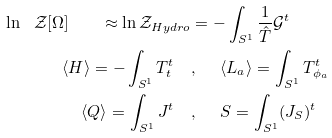<formula> <loc_0><loc_0><loc_500><loc_500>\ln \ \mathcal { Z } [ \Omega ] \quad \approx \ln \mathcal { Z } _ { H y d r o } & = - \int _ { S ^ { 1 } } \frac { 1 } { \hat { T } } \mathcal { G } ^ { t } \\ \langle H \rangle = - \int _ { S ^ { 1 } } T ^ { t } _ { t } \quad & , \ \quad \langle L _ { a } \rangle = \int _ { S ^ { 1 } } T ^ { t } _ { \phi _ { a } } \\ \langle Q \rangle = \int _ { S ^ { 1 } } J ^ { t } \quad & , \ \quad S = \int _ { S ^ { 1 } } ( J _ { S } ) ^ { t } \\</formula> 